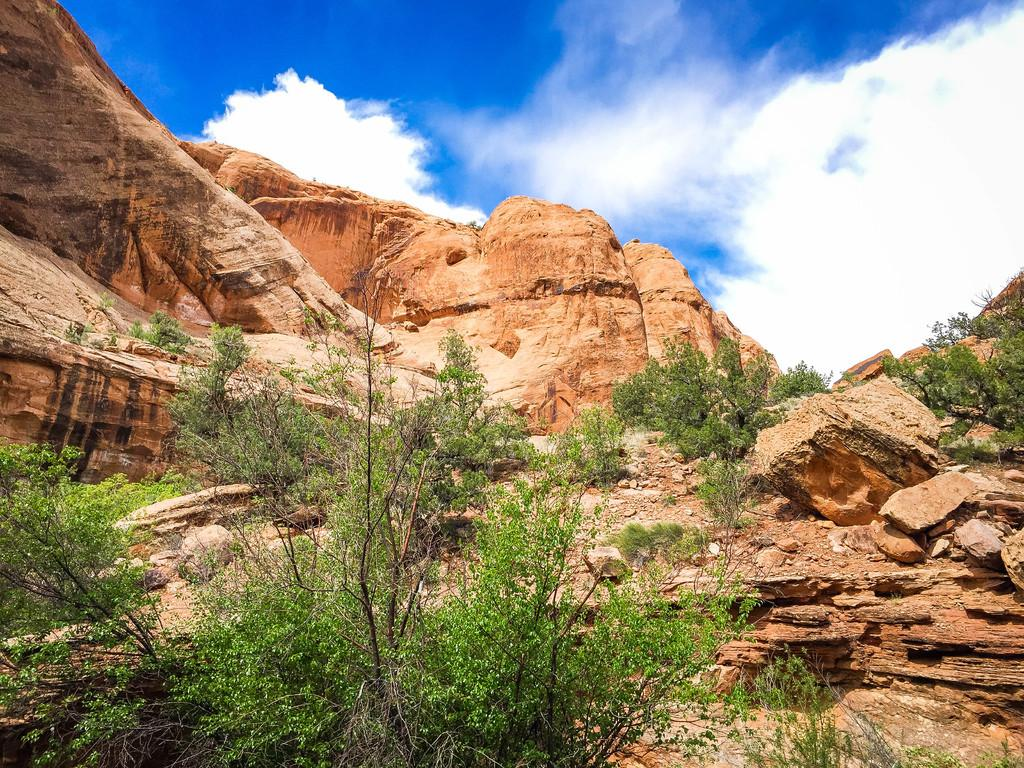What type of natural landscape can be seen in the image? There are hills in the image. What other elements are present in the landscape? There are rocks, trees, and plants in the image. What is visible in the sky in the image? The sky is visible in the image, and clouds are present. What type of steam can be seen coming from the rocks in the image? There is no steam present in the image; it is a landscape with rocks, trees, plants, and a sky with clouds. 